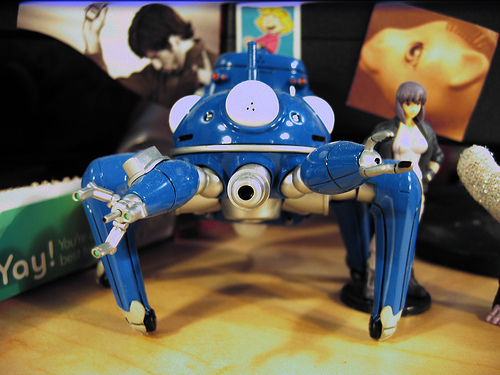<image>
Is the robot in front of the horse? Yes. The robot is positioned in front of the horse, appearing closer to the camera viewpoint. 